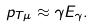Convert formula to latex. <formula><loc_0><loc_0><loc_500><loc_500>p _ { T \mu } \approx \gamma E _ { \gamma } .</formula> 